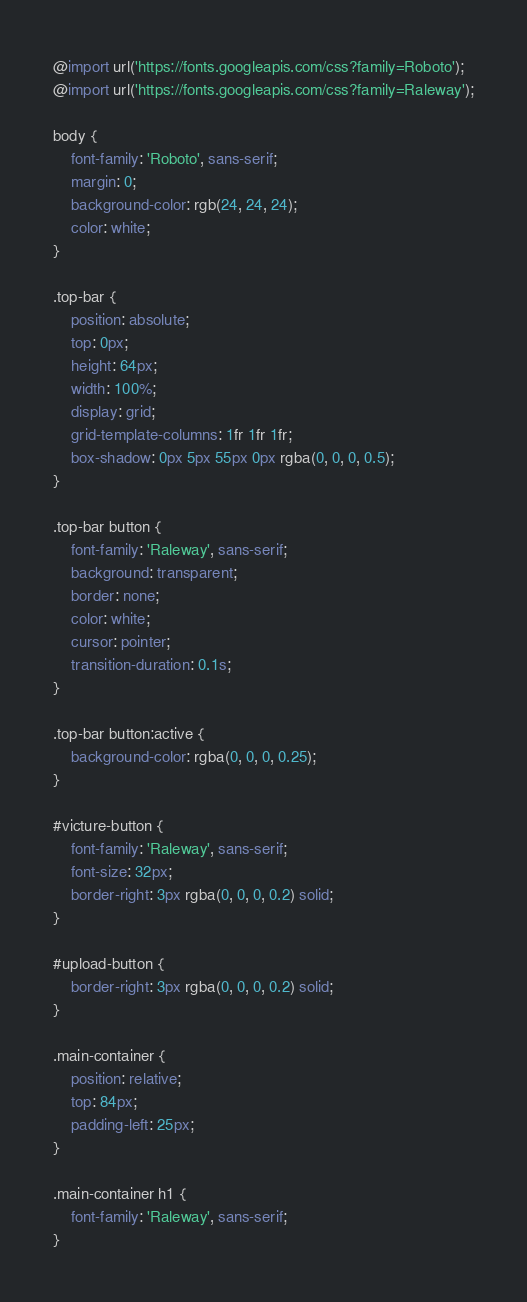Convert code to text. <code><loc_0><loc_0><loc_500><loc_500><_CSS_>@import url('https://fonts.googleapis.com/css?family=Roboto');
@import url('https://fonts.googleapis.com/css?family=Raleway');

body {
    font-family: 'Roboto', sans-serif;
    margin: 0;
    background-color: rgb(24, 24, 24);
    color: white;
}

.top-bar {
    position: absolute;
    top: 0px;
    height: 64px;
    width: 100%;
    display: grid;
    grid-template-columns: 1fr 1fr 1fr;
    box-shadow: 0px 5px 55px 0px rgba(0, 0, 0, 0.5);
}

.top-bar button {
    font-family: 'Raleway', sans-serif;
    background: transparent;
    border: none;
    color: white;
    cursor: pointer;
    transition-duration: 0.1s;
}

.top-bar button:active {
    background-color: rgba(0, 0, 0, 0.25);
}

#victure-button {
    font-family: 'Raleway', sans-serif;
    font-size: 32px;
    border-right: 3px rgba(0, 0, 0, 0.2) solid;
}

#upload-button {
    border-right: 3px rgba(0, 0, 0, 0.2) solid;
}

.main-container {
    position: relative;
    top: 84px;
    padding-left: 25px;
}

.main-container h1 {
    font-family: 'Raleway', sans-serif;
}</code> 